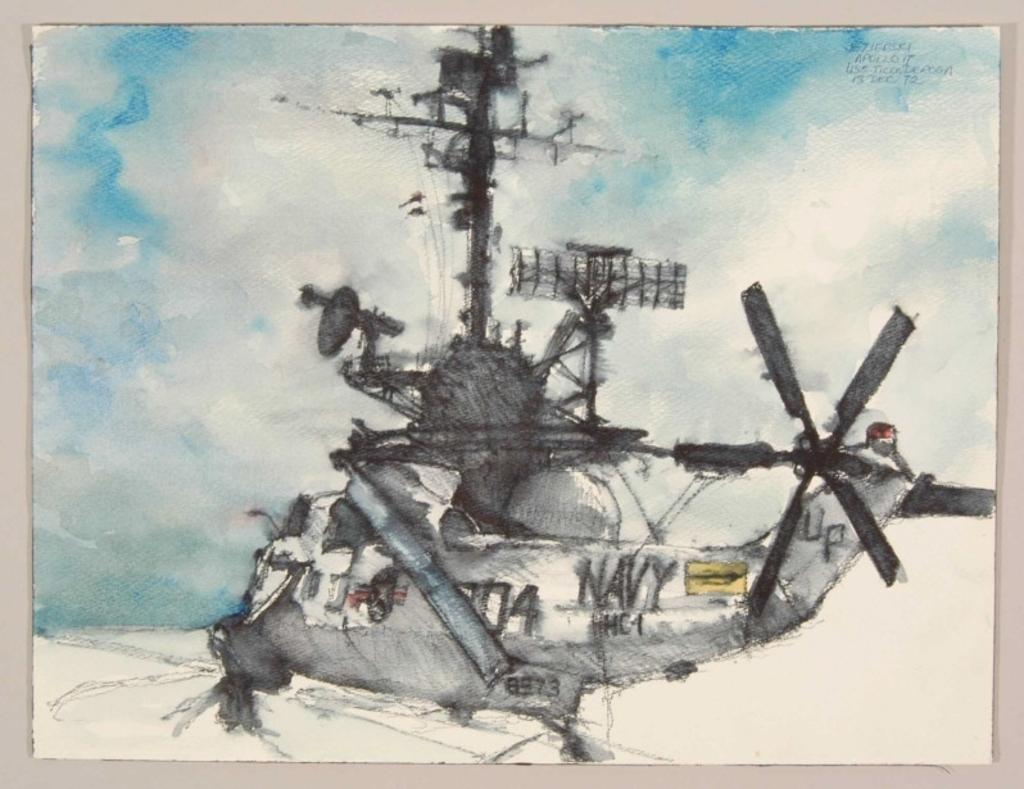What is the main subject of the picture? The main subject of the picture is a helicopter. Does the helicopter have any unique features? Yes, the helicopter has special equipment. What is the condition of the sky in the picture? The sky is clear in the picture. How is the picture created? The image is a painting. How many apples are hanging from the helicopter in the image? There are no apples present in the image, as it features a helicopter with special equipment against a clear sky. What is the value of the helicopter in the image? The value of the helicopter cannot be determined from the image alone, as it only provides a visual representation. 